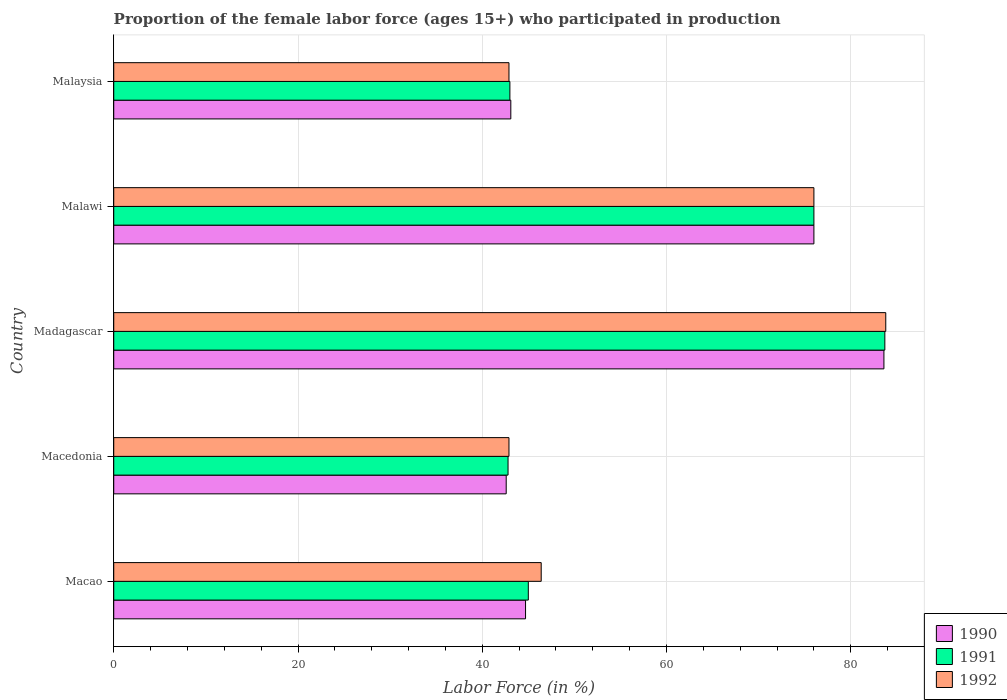How many groups of bars are there?
Provide a short and direct response. 5. Are the number of bars on each tick of the Y-axis equal?
Ensure brevity in your answer.  Yes. What is the label of the 3rd group of bars from the top?
Your answer should be compact. Madagascar. What is the proportion of the female labor force who participated in production in 1990 in Macao?
Your answer should be compact. 44.7. Across all countries, what is the maximum proportion of the female labor force who participated in production in 1991?
Make the answer very short. 83.7. Across all countries, what is the minimum proportion of the female labor force who participated in production in 1991?
Provide a short and direct response. 42.8. In which country was the proportion of the female labor force who participated in production in 1990 maximum?
Your response must be concise. Madagascar. In which country was the proportion of the female labor force who participated in production in 1991 minimum?
Your response must be concise. Macedonia. What is the total proportion of the female labor force who participated in production in 1990 in the graph?
Your answer should be compact. 290. What is the difference between the proportion of the female labor force who participated in production in 1992 in Macedonia and that in Malaysia?
Give a very brief answer. 0. What is the difference between the proportion of the female labor force who participated in production in 1990 in Macao and the proportion of the female labor force who participated in production in 1991 in Malaysia?
Provide a succinct answer. 1.7. What is the average proportion of the female labor force who participated in production in 1990 per country?
Offer a terse response. 58. What is the difference between the proportion of the female labor force who participated in production in 1992 and proportion of the female labor force who participated in production in 1991 in Madagascar?
Make the answer very short. 0.1. In how many countries, is the proportion of the female labor force who participated in production in 1991 greater than 52 %?
Offer a very short reply. 2. What is the ratio of the proportion of the female labor force who participated in production in 1992 in Malawi to that in Malaysia?
Provide a succinct answer. 1.77. Is the difference between the proportion of the female labor force who participated in production in 1992 in Macao and Malaysia greater than the difference between the proportion of the female labor force who participated in production in 1991 in Macao and Malaysia?
Provide a succinct answer. Yes. What is the difference between the highest and the second highest proportion of the female labor force who participated in production in 1991?
Make the answer very short. 7.7. What is the difference between the highest and the lowest proportion of the female labor force who participated in production in 1991?
Offer a very short reply. 40.9. Is the sum of the proportion of the female labor force who participated in production in 1991 in Madagascar and Malaysia greater than the maximum proportion of the female labor force who participated in production in 1992 across all countries?
Make the answer very short. Yes. What does the 1st bar from the top in Macao represents?
Your response must be concise. 1992. Is it the case that in every country, the sum of the proportion of the female labor force who participated in production in 1992 and proportion of the female labor force who participated in production in 1990 is greater than the proportion of the female labor force who participated in production in 1991?
Offer a very short reply. Yes. How many bars are there?
Keep it short and to the point. 15. How many countries are there in the graph?
Offer a terse response. 5. How many legend labels are there?
Offer a very short reply. 3. How are the legend labels stacked?
Ensure brevity in your answer.  Vertical. What is the title of the graph?
Offer a very short reply. Proportion of the female labor force (ages 15+) who participated in production. What is the label or title of the Y-axis?
Ensure brevity in your answer.  Country. What is the Labor Force (in %) of 1990 in Macao?
Offer a terse response. 44.7. What is the Labor Force (in %) in 1992 in Macao?
Ensure brevity in your answer.  46.4. What is the Labor Force (in %) in 1990 in Macedonia?
Ensure brevity in your answer.  42.6. What is the Labor Force (in %) in 1991 in Macedonia?
Ensure brevity in your answer.  42.8. What is the Labor Force (in %) in 1992 in Macedonia?
Offer a very short reply. 42.9. What is the Labor Force (in %) of 1990 in Madagascar?
Ensure brevity in your answer.  83.6. What is the Labor Force (in %) of 1991 in Madagascar?
Your answer should be very brief. 83.7. What is the Labor Force (in %) in 1992 in Madagascar?
Offer a terse response. 83.8. What is the Labor Force (in %) of 1990 in Malawi?
Keep it short and to the point. 76. What is the Labor Force (in %) in 1990 in Malaysia?
Give a very brief answer. 43.1. What is the Labor Force (in %) of 1991 in Malaysia?
Your response must be concise. 43. What is the Labor Force (in %) of 1992 in Malaysia?
Your answer should be compact. 42.9. Across all countries, what is the maximum Labor Force (in %) in 1990?
Offer a very short reply. 83.6. Across all countries, what is the maximum Labor Force (in %) in 1991?
Make the answer very short. 83.7. Across all countries, what is the maximum Labor Force (in %) in 1992?
Make the answer very short. 83.8. Across all countries, what is the minimum Labor Force (in %) in 1990?
Provide a succinct answer. 42.6. Across all countries, what is the minimum Labor Force (in %) of 1991?
Your answer should be very brief. 42.8. Across all countries, what is the minimum Labor Force (in %) in 1992?
Offer a very short reply. 42.9. What is the total Labor Force (in %) of 1990 in the graph?
Ensure brevity in your answer.  290. What is the total Labor Force (in %) in 1991 in the graph?
Ensure brevity in your answer.  290.5. What is the total Labor Force (in %) in 1992 in the graph?
Make the answer very short. 292. What is the difference between the Labor Force (in %) of 1990 in Macao and that in Macedonia?
Ensure brevity in your answer.  2.1. What is the difference between the Labor Force (in %) of 1990 in Macao and that in Madagascar?
Your answer should be compact. -38.9. What is the difference between the Labor Force (in %) in 1991 in Macao and that in Madagascar?
Provide a succinct answer. -38.7. What is the difference between the Labor Force (in %) of 1992 in Macao and that in Madagascar?
Give a very brief answer. -37.4. What is the difference between the Labor Force (in %) in 1990 in Macao and that in Malawi?
Make the answer very short. -31.3. What is the difference between the Labor Force (in %) in 1991 in Macao and that in Malawi?
Offer a terse response. -31. What is the difference between the Labor Force (in %) of 1992 in Macao and that in Malawi?
Keep it short and to the point. -29.6. What is the difference between the Labor Force (in %) in 1992 in Macao and that in Malaysia?
Offer a very short reply. 3.5. What is the difference between the Labor Force (in %) in 1990 in Macedonia and that in Madagascar?
Make the answer very short. -41. What is the difference between the Labor Force (in %) of 1991 in Macedonia and that in Madagascar?
Your answer should be very brief. -40.9. What is the difference between the Labor Force (in %) in 1992 in Macedonia and that in Madagascar?
Give a very brief answer. -40.9. What is the difference between the Labor Force (in %) of 1990 in Macedonia and that in Malawi?
Offer a terse response. -33.4. What is the difference between the Labor Force (in %) of 1991 in Macedonia and that in Malawi?
Your answer should be very brief. -33.2. What is the difference between the Labor Force (in %) of 1992 in Macedonia and that in Malawi?
Your answer should be very brief. -33.1. What is the difference between the Labor Force (in %) of 1991 in Macedonia and that in Malaysia?
Provide a succinct answer. -0.2. What is the difference between the Labor Force (in %) of 1992 in Macedonia and that in Malaysia?
Offer a very short reply. 0. What is the difference between the Labor Force (in %) of 1991 in Madagascar and that in Malawi?
Offer a terse response. 7.7. What is the difference between the Labor Force (in %) of 1990 in Madagascar and that in Malaysia?
Your answer should be very brief. 40.5. What is the difference between the Labor Force (in %) in 1991 in Madagascar and that in Malaysia?
Provide a succinct answer. 40.7. What is the difference between the Labor Force (in %) of 1992 in Madagascar and that in Malaysia?
Give a very brief answer. 40.9. What is the difference between the Labor Force (in %) in 1990 in Malawi and that in Malaysia?
Provide a short and direct response. 32.9. What is the difference between the Labor Force (in %) in 1991 in Malawi and that in Malaysia?
Ensure brevity in your answer.  33. What is the difference between the Labor Force (in %) in 1992 in Malawi and that in Malaysia?
Your answer should be compact. 33.1. What is the difference between the Labor Force (in %) of 1990 in Macao and the Labor Force (in %) of 1991 in Macedonia?
Offer a very short reply. 1.9. What is the difference between the Labor Force (in %) of 1990 in Macao and the Labor Force (in %) of 1992 in Macedonia?
Offer a terse response. 1.8. What is the difference between the Labor Force (in %) in 1990 in Macao and the Labor Force (in %) in 1991 in Madagascar?
Offer a very short reply. -39. What is the difference between the Labor Force (in %) in 1990 in Macao and the Labor Force (in %) in 1992 in Madagascar?
Keep it short and to the point. -39.1. What is the difference between the Labor Force (in %) of 1991 in Macao and the Labor Force (in %) of 1992 in Madagascar?
Offer a terse response. -38.8. What is the difference between the Labor Force (in %) of 1990 in Macao and the Labor Force (in %) of 1991 in Malawi?
Give a very brief answer. -31.3. What is the difference between the Labor Force (in %) in 1990 in Macao and the Labor Force (in %) in 1992 in Malawi?
Make the answer very short. -31.3. What is the difference between the Labor Force (in %) in 1991 in Macao and the Labor Force (in %) in 1992 in Malawi?
Give a very brief answer. -31. What is the difference between the Labor Force (in %) of 1990 in Macao and the Labor Force (in %) of 1991 in Malaysia?
Your response must be concise. 1.7. What is the difference between the Labor Force (in %) of 1990 in Macedonia and the Labor Force (in %) of 1991 in Madagascar?
Give a very brief answer. -41.1. What is the difference between the Labor Force (in %) in 1990 in Macedonia and the Labor Force (in %) in 1992 in Madagascar?
Make the answer very short. -41.2. What is the difference between the Labor Force (in %) of 1991 in Macedonia and the Labor Force (in %) of 1992 in Madagascar?
Provide a succinct answer. -41. What is the difference between the Labor Force (in %) in 1990 in Macedonia and the Labor Force (in %) in 1991 in Malawi?
Offer a terse response. -33.4. What is the difference between the Labor Force (in %) of 1990 in Macedonia and the Labor Force (in %) of 1992 in Malawi?
Provide a succinct answer. -33.4. What is the difference between the Labor Force (in %) of 1991 in Macedonia and the Labor Force (in %) of 1992 in Malawi?
Your answer should be very brief. -33.2. What is the difference between the Labor Force (in %) of 1990 in Madagascar and the Labor Force (in %) of 1991 in Malawi?
Offer a very short reply. 7.6. What is the difference between the Labor Force (in %) of 1990 in Madagascar and the Labor Force (in %) of 1992 in Malawi?
Your response must be concise. 7.6. What is the difference between the Labor Force (in %) in 1990 in Madagascar and the Labor Force (in %) in 1991 in Malaysia?
Provide a short and direct response. 40.6. What is the difference between the Labor Force (in %) of 1990 in Madagascar and the Labor Force (in %) of 1992 in Malaysia?
Provide a succinct answer. 40.7. What is the difference between the Labor Force (in %) in 1991 in Madagascar and the Labor Force (in %) in 1992 in Malaysia?
Offer a terse response. 40.8. What is the difference between the Labor Force (in %) of 1990 in Malawi and the Labor Force (in %) of 1992 in Malaysia?
Your answer should be very brief. 33.1. What is the difference between the Labor Force (in %) of 1991 in Malawi and the Labor Force (in %) of 1992 in Malaysia?
Ensure brevity in your answer.  33.1. What is the average Labor Force (in %) in 1991 per country?
Offer a very short reply. 58.1. What is the average Labor Force (in %) in 1992 per country?
Provide a short and direct response. 58.4. What is the difference between the Labor Force (in %) of 1990 and Labor Force (in %) of 1991 in Macao?
Offer a terse response. -0.3. What is the difference between the Labor Force (in %) in 1990 and Labor Force (in %) in 1992 in Macao?
Make the answer very short. -1.7. What is the difference between the Labor Force (in %) in 1991 and Labor Force (in %) in 1992 in Macao?
Ensure brevity in your answer.  -1.4. What is the difference between the Labor Force (in %) of 1990 and Labor Force (in %) of 1992 in Macedonia?
Keep it short and to the point. -0.3. What is the difference between the Labor Force (in %) in 1991 and Labor Force (in %) in 1992 in Macedonia?
Ensure brevity in your answer.  -0.1. What is the difference between the Labor Force (in %) of 1990 and Labor Force (in %) of 1991 in Madagascar?
Give a very brief answer. -0.1. What is the difference between the Labor Force (in %) of 1990 and Labor Force (in %) of 1992 in Madagascar?
Provide a succinct answer. -0.2. What is the difference between the Labor Force (in %) of 1990 and Labor Force (in %) of 1992 in Malawi?
Provide a succinct answer. 0. What is the difference between the Labor Force (in %) in 1990 and Labor Force (in %) in 1991 in Malaysia?
Offer a very short reply. 0.1. What is the ratio of the Labor Force (in %) of 1990 in Macao to that in Macedonia?
Offer a terse response. 1.05. What is the ratio of the Labor Force (in %) of 1991 in Macao to that in Macedonia?
Make the answer very short. 1.05. What is the ratio of the Labor Force (in %) in 1992 in Macao to that in Macedonia?
Your answer should be very brief. 1.08. What is the ratio of the Labor Force (in %) in 1990 in Macao to that in Madagascar?
Offer a very short reply. 0.53. What is the ratio of the Labor Force (in %) in 1991 in Macao to that in Madagascar?
Provide a succinct answer. 0.54. What is the ratio of the Labor Force (in %) in 1992 in Macao to that in Madagascar?
Your answer should be very brief. 0.55. What is the ratio of the Labor Force (in %) of 1990 in Macao to that in Malawi?
Provide a succinct answer. 0.59. What is the ratio of the Labor Force (in %) of 1991 in Macao to that in Malawi?
Your answer should be compact. 0.59. What is the ratio of the Labor Force (in %) in 1992 in Macao to that in Malawi?
Your response must be concise. 0.61. What is the ratio of the Labor Force (in %) of 1990 in Macao to that in Malaysia?
Give a very brief answer. 1.04. What is the ratio of the Labor Force (in %) of 1991 in Macao to that in Malaysia?
Your response must be concise. 1.05. What is the ratio of the Labor Force (in %) of 1992 in Macao to that in Malaysia?
Your answer should be compact. 1.08. What is the ratio of the Labor Force (in %) in 1990 in Macedonia to that in Madagascar?
Offer a very short reply. 0.51. What is the ratio of the Labor Force (in %) of 1991 in Macedonia to that in Madagascar?
Give a very brief answer. 0.51. What is the ratio of the Labor Force (in %) in 1992 in Macedonia to that in Madagascar?
Your answer should be compact. 0.51. What is the ratio of the Labor Force (in %) of 1990 in Macedonia to that in Malawi?
Offer a terse response. 0.56. What is the ratio of the Labor Force (in %) in 1991 in Macedonia to that in Malawi?
Keep it short and to the point. 0.56. What is the ratio of the Labor Force (in %) of 1992 in Macedonia to that in Malawi?
Keep it short and to the point. 0.56. What is the ratio of the Labor Force (in %) in 1990 in Macedonia to that in Malaysia?
Your response must be concise. 0.99. What is the ratio of the Labor Force (in %) of 1991 in Macedonia to that in Malaysia?
Provide a short and direct response. 1. What is the ratio of the Labor Force (in %) of 1992 in Macedonia to that in Malaysia?
Ensure brevity in your answer.  1. What is the ratio of the Labor Force (in %) in 1991 in Madagascar to that in Malawi?
Your answer should be very brief. 1.1. What is the ratio of the Labor Force (in %) in 1992 in Madagascar to that in Malawi?
Your answer should be very brief. 1.1. What is the ratio of the Labor Force (in %) in 1990 in Madagascar to that in Malaysia?
Provide a short and direct response. 1.94. What is the ratio of the Labor Force (in %) of 1991 in Madagascar to that in Malaysia?
Ensure brevity in your answer.  1.95. What is the ratio of the Labor Force (in %) of 1992 in Madagascar to that in Malaysia?
Your response must be concise. 1.95. What is the ratio of the Labor Force (in %) of 1990 in Malawi to that in Malaysia?
Offer a very short reply. 1.76. What is the ratio of the Labor Force (in %) of 1991 in Malawi to that in Malaysia?
Your answer should be very brief. 1.77. What is the ratio of the Labor Force (in %) in 1992 in Malawi to that in Malaysia?
Provide a succinct answer. 1.77. What is the difference between the highest and the second highest Labor Force (in %) in 1990?
Your answer should be very brief. 7.6. What is the difference between the highest and the second highest Labor Force (in %) in 1991?
Offer a terse response. 7.7. What is the difference between the highest and the lowest Labor Force (in %) of 1990?
Ensure brevity in your answer.  41. What is the difference between the highest and the lowest Labor Force (in %) in 1991?
Your response must be concise. 40.9. What is the difference between the highest and the lowest Labor Force (in %) in 1992?
Your answer should be very brief. 40.9. 